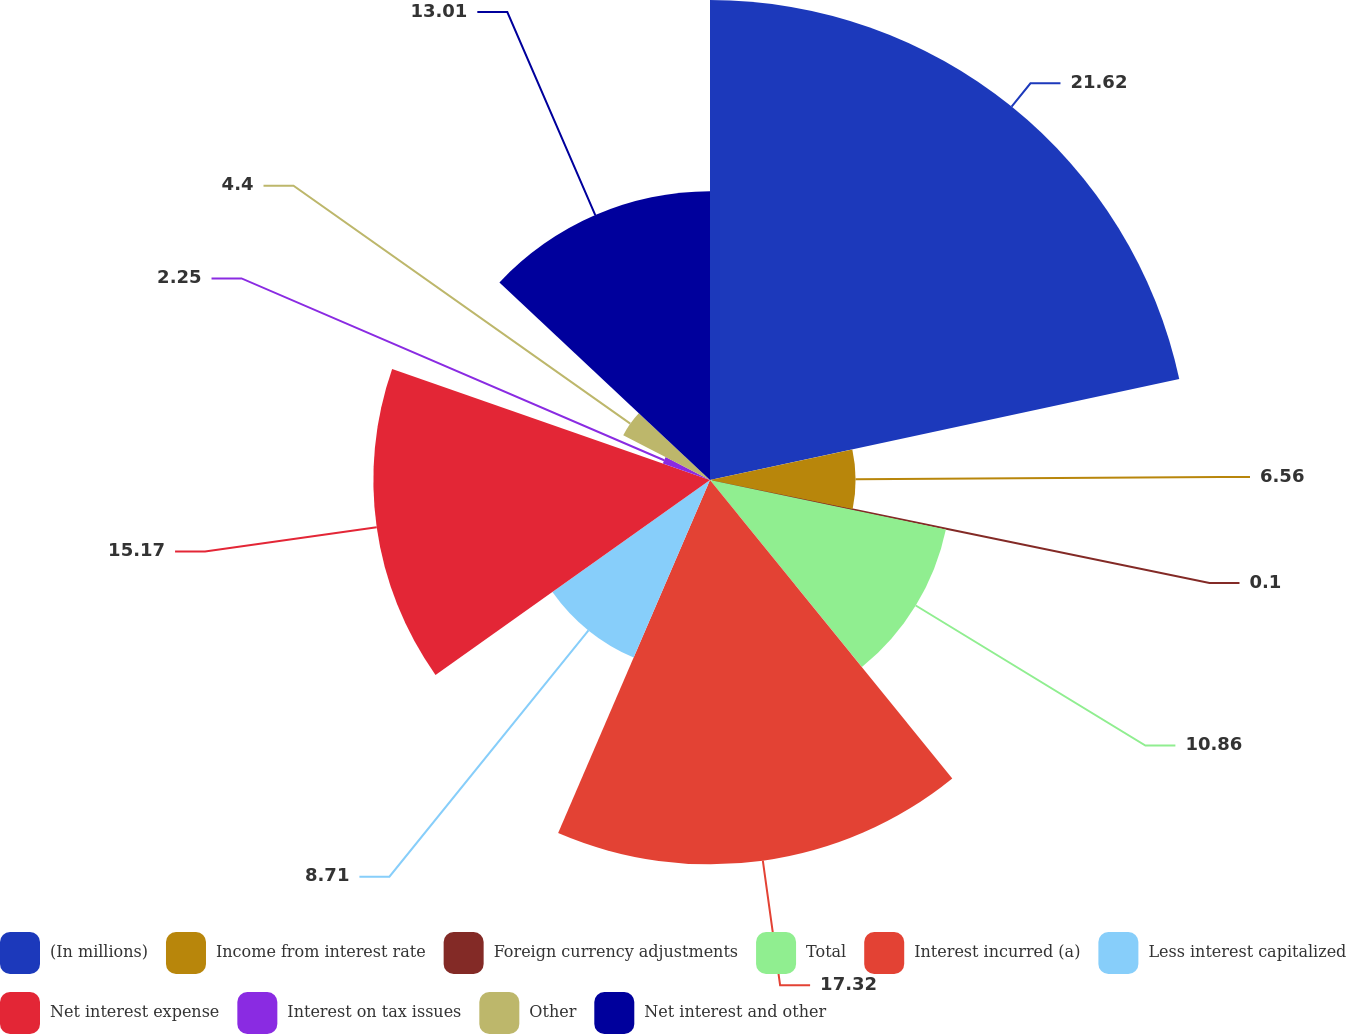Convert chart. <chart><loc_0><loc_0><loc_500><loc_500><pie_chart><fcel>(In millions)<fcel>Income from interest rate<fcel>Foreign currency adjustments<fcel>Total<fcel>Interest incurred (a)<fcel>Less interest capitalized<fcel>Net interest expense<fcel>Interest on tax issues<fcel>Other<fcel>Net interest and other<nl><fcel>21.63%<fcel>6.56%<fcel>0.1%<fcel>10.86%<fcel>17.32%<fcel>8.71%<fcel>15.17%<fcel>2.25%<fcel>4.4%<fcel>13.01%<nl></chart> 